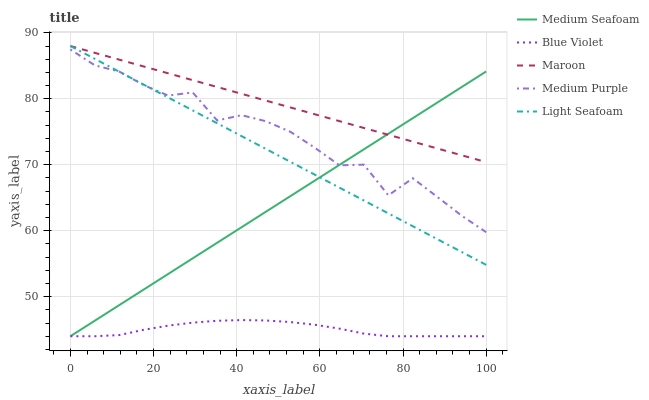Does Blue Violet have the minimum area under the curve?
Answer yes or no. Yes. Does Maroon have the maximum area under the curve?
Answer yes or no. Yes. Does Light Seafoam have the minimum area under the curve?
Answer yes or no. No. Does Light Seafoam have the maximum area under the curve?
Answer yes or no. No. Is Medium Seafoam the smoothest?
Answer yes or no. Yes. Is Medium Purple the roughest?
Answer yes or no. Yes. Is Maroon the smoothest?
Answer yes or no. No. Is Maroon the roughest?
Answer yes or no. No. Does Light Seafoam have the lowest value?
Answer yes or no. No. Does Light Seafoam have the highest value?
Answer yes or no. Yes. Does Medium Seafoam have the highest value?
Answer yes or no. No. Is Blue Violet less than Maroon?
Answer yes or no. Yes. Is Maroon greater than Blue Violet?
Answer yes or no. Yes. Does Light Seafoam intersect Medium Purple?
Answer yes or no. Yes. Is Light Seafoam less than Medium Purple?
Answer yes or no. No. Is Light Seafoam greater than Medium Purple?
Answer yes or no. No. Does Blue Violet intersect Maroon?
Answer yes or no. No. 